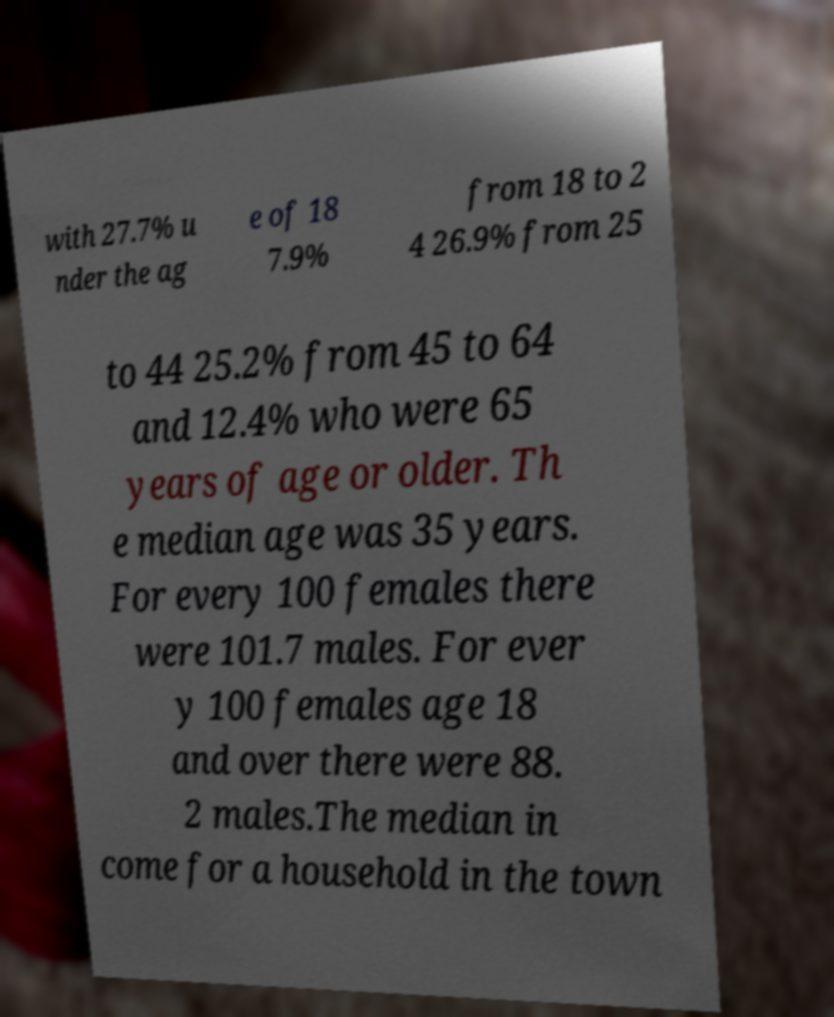Could you assist in decoding the text presented in this image and type it out clearly? with 27.7% u nder the ag e of 18 7.9% from 18 to 2 4 26.9% from 25 to 44 25.2% from 45 to 64 and 12.4% who were 65 years of age or older. Th e median age was 35 years. For every 100 females there were 101.7 males. For ever y 100 females age 18 and over there were 88. 2 males.The median in come for a household in the town 